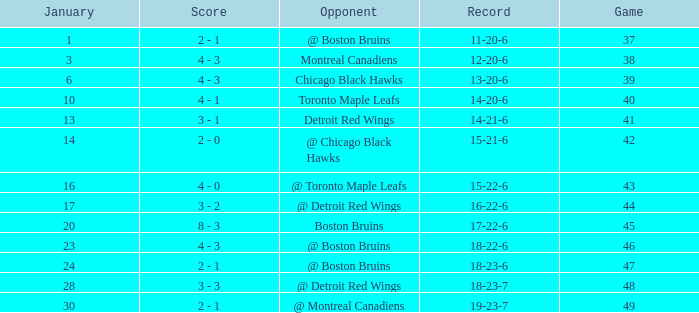What was the entire sum of games on january 20? 1.0. 